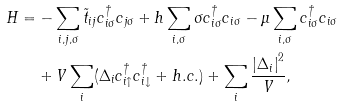Convert formula to latex. <formula><loc_0><loc_0><loc_500><loc_500>H = & - \sum _ { i , j , \sigma } \tilde { t } _ { i j } c _ { i \sigma } ^ { \dagger } c _ { j \sigma } + h \sum _ { i , \sigma } \sigma c _ { i \sigma } ^ { \dagger } c _ { i \sigma } - \mu \sum _ { i , \sigma } c _ { i \sigma } ^ { \dagger } c _ { i \sigma } \\ & + V \sum _ { i } ( \Delta _ { i } c _ { i \uparrow } ^ { \dagger } c _ { i \downarrow } ^ { \dagger } + h . c . ) + \sum _ { i } \frac { \left | \Delta _ { i } \right | ^ { 2 } } { V } ,</formula> 